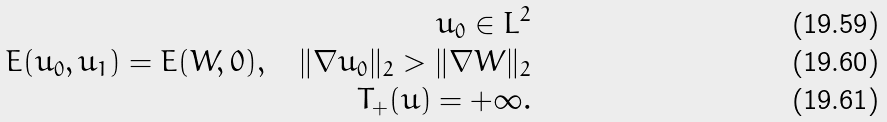<formula> <loc_0><loc_0><loc_500><loc_500>u _ { 0 } \in L ^ { 2 } \\ E ( u _ { 0 } , u _ { 1 } ) = E ( W , 0 ) , \quad \| \nabla u _ { 0 } \| _ { 2 } > \| \nabla W \| _ { 2 } \\ T _ { + } ( u ) = + \infty .</formula> 